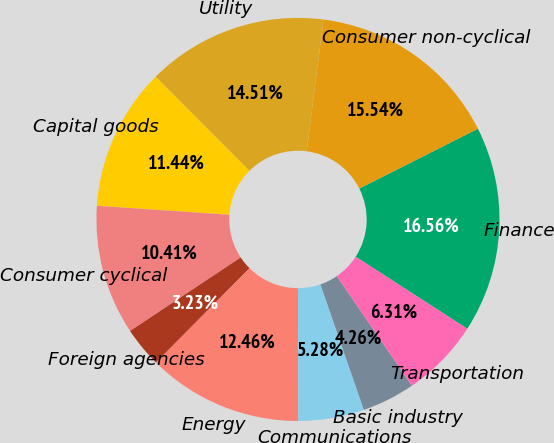Convert chart to OTSL. <chart><loc_0><loc_0><loc_500><loc_500><pie_chart><fcel>Finance<fcel>Consumer non-cyclical<fcel>Utility<fcel>Capital goods<fcel>Consumer cyclical<fcel>Foreign agencies<fcel>Energy<fcel>Communications<fcel>Basic industry<fcel>Transportation<nl><fcel>16.56%<fcel>15.54%<fcel>14.51%<fcel>11.44%<fcel>10.41%<fcel>3.23%<fcel>12.46%<fcel>5.28%<fcel>4.26%<fcel>6.31%<nl></chart> 